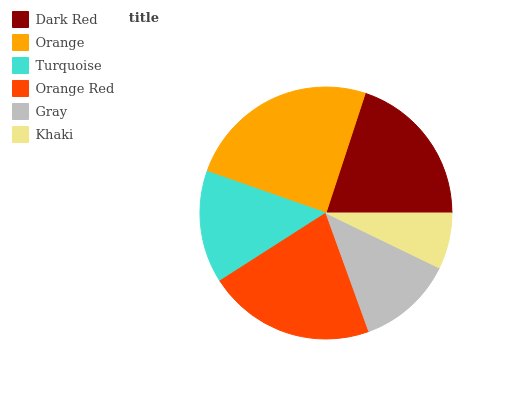Is Khaki the minimum?
Answer yes or no. Yes. Is Orange the maximum?
Answer yes or no. Yes. Is Turquoise the minimum?
Answer yes or no. No. Is Turquoise the maximum?
Answer yes or no. No. Is Orange greater than Turquoise?
Answer yes or no. Yes. Is Turquoise less than Orange?
Answer yes or no. Yes. Is Turquoise greater than Orange?
Answer yes or no. No. Is Orange less than Turquoise?
Answer yes or no. No. Is Dark Red the high median?
Answer yes or no. Yes. Is Turquoise the low median?
Answer yes or no. Yes. Is Khaki the high median?
Answer yes or no. No. Is Gray the low median?
Answer yes or no. No. 